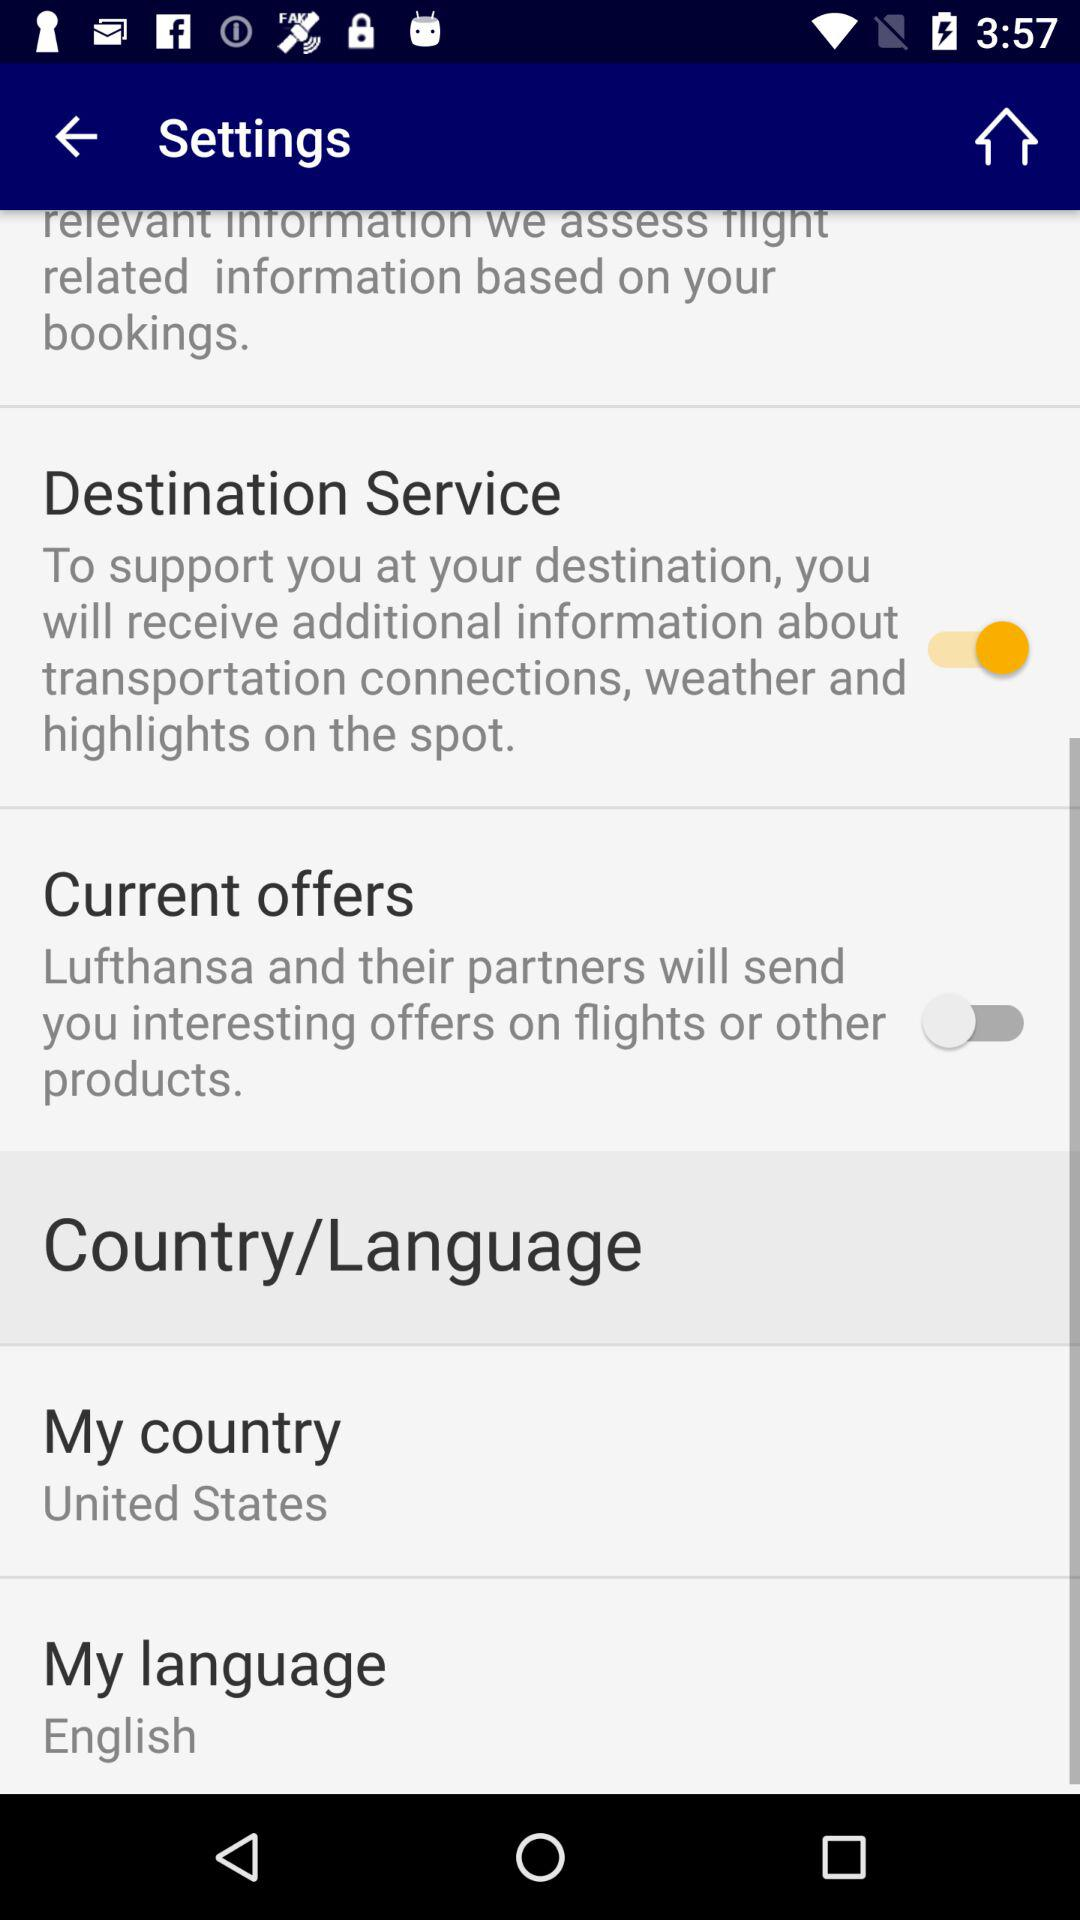What is the name of the application?
When the provided information is insufficient, respond with <no answer>. <no answer> 